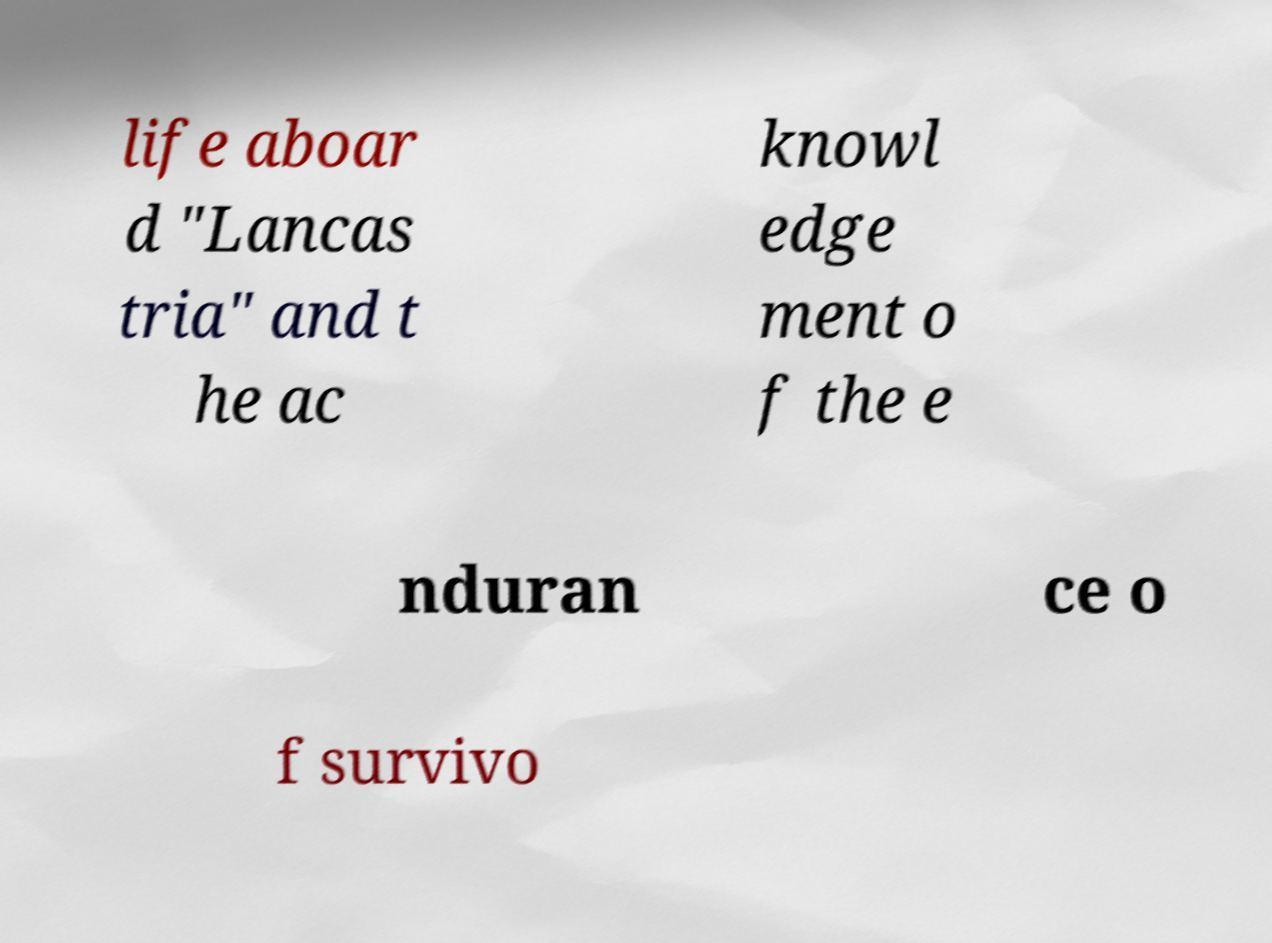Can you read and provide the text displayed in the image?This photo seems to have some interesting text. Can you extract and type it out for me? life aboar d "Lancas tria" and t he ac knowl edge ment o f the e nduran ce o f survivo 